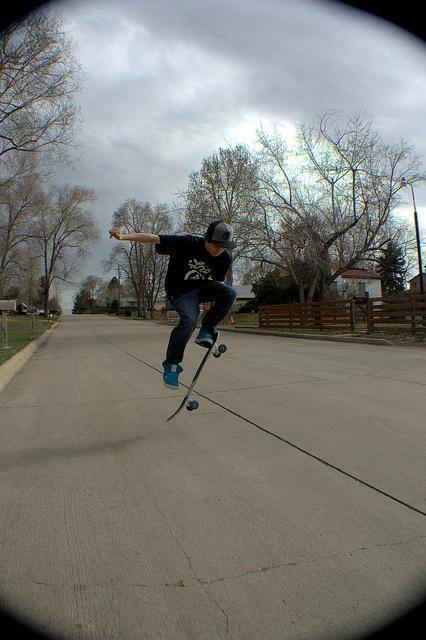How many zebras are facing forward?
Give a very brief answer. 0. 